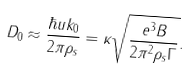Convert formula to latex. <formula><loc_0><loc_0><loc_500><loc_500>D _ { 0 } \approx \frac { \hbar { u } k _ { 0 } } { 2 \pi \rho _ { s } } = \kappa \sqrt { \frac { e ^ { 3 } B } { 2 \pi ^ { 2 } \rho _ { s } \Gamma } } .</formula> 